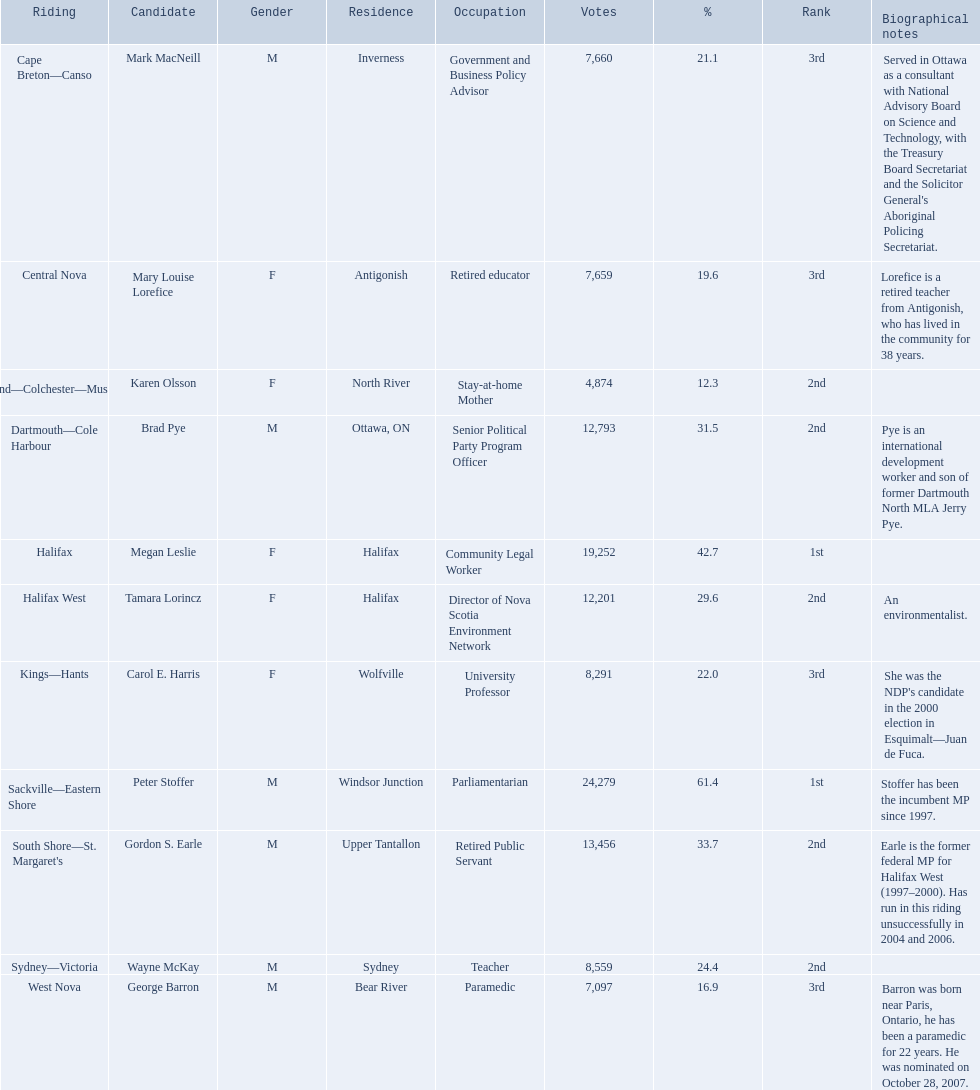Who were all the new democratic party nominees in the 2008 canadian federal election? Mark MacNeill, Mary Louise Lorefice, Karen Olsson, Brad Pye, Megan Leslie, Tamara Lorincz, Carol E. Harris, Peter Stoffer, Gordon S. Earle, Wayne McKay, George Barron. And between mark macneill and karen olsson, which one obtained more votes? Mark MacNeill. Parse the full table. {'header': ['Riding', 'Candidate', 'Gender', 'Residence', 'Occupation', 'Votes', '%', 'Rank', 'Biographical notes'], 'rows': [['Cape Breton—Canso', 'Mark MacNeill', 'M', 'Inverness', 'Government and Business Policy Advisor', '7,660', '21.1', '3rd', "Served in Ottawa as a consultant with National Advisory Board on Science and Technology, with the Treasury Board Secretariat and the Solicitor General's Aboriginal Policing Secretariat."], ['Central Nova', 'Mary Louise Lorefice', 'F', 'Antigonish', 'Retired educator', '7,659', '19.6', '3rd', 'Lorefice is a retired teacher from Antigonish, who has lived in the community for 38 years.'], ['Cumberland—Colchester—Musquodoboit Valley', 'Karen Olsson', 'F', 'North River', 'Stay-at-home Mother', '4,874', '12.3', '2nd', ''], ['Dartmouth—Cole Harbour', 'Brad Pye', 'M', 'Ottawa, ON', 'Senior Political Party Program Officer', '12,793', '31.5', '2nd', 'Pye is an international development worker and son of former Dartmouth North MLA Jerry Pye.'], ['Halifax', 'Megan Leslie', 'F', 'Halifax', 'Community Legal Worker', '19,252', '42.7', '1st', ''], ['Halifax West', 'Tamara Lorincz', 'F', 'Halifax', 'Director of Nova Scotia Environment Network', '12,201', '29.6', '2nd', 'An environmentalist.'], ['Kings—Hants', 'Carol E. Harris', 'F', 'Wolfville', 'University Professor', '8,291', '22.0', '3rd', "She was the NDP's candidate in the 2000 election in Esquimalt—Juan de Fuca."], ['Sackville—Eastern Shore', 'Peter Stoffer', 'M', 'Windsor Junction', 'Parliamentarian', '24,279', '61.4', '1st', 'Stoffer has been the incumbent MP since 1997.'], ["South Shore—St. Margaret's", 'Gordon S. Earle', 'M', 'Upper Tantallon', 'Retired Public Servant', '13,456', '33.7', '2nd', 'Earle is the former federal MP for Halifax West (1997–2000). Has run in this riding unsuccessfully in 2004 and 2006.'], ['Sydney—Victoria', 'Wayne McKay', 'M', 'Sydney', 'Teacher', '8,559', '24.4', '2nd', ''], ['West Nova', 'George Barron', 'M', 'Bear River', 'Paramedic', '7,097', '16.9', '3rd', 'Barron was born near Paris, Ontario, he has been a paramedic for 22 years. He was nominated on October 28, 2007.']]} 